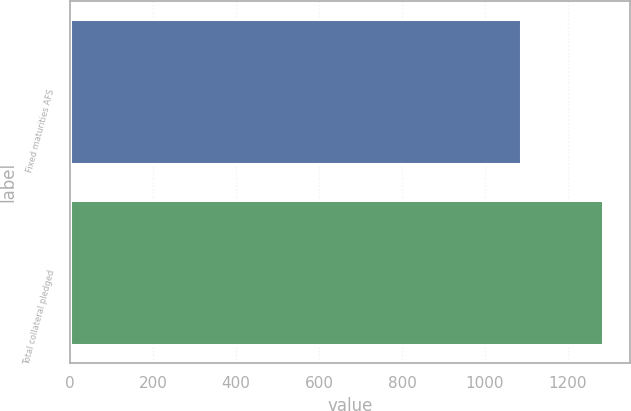Convert chart to OTSL. <chart><loc_0><loc_0><loc_500><loc_500><bar_chart><fcel>Fixed maturities AFS<fcel>Total collateral pledged<nl><fcel>1086<fcel>1285<nl></chart> 